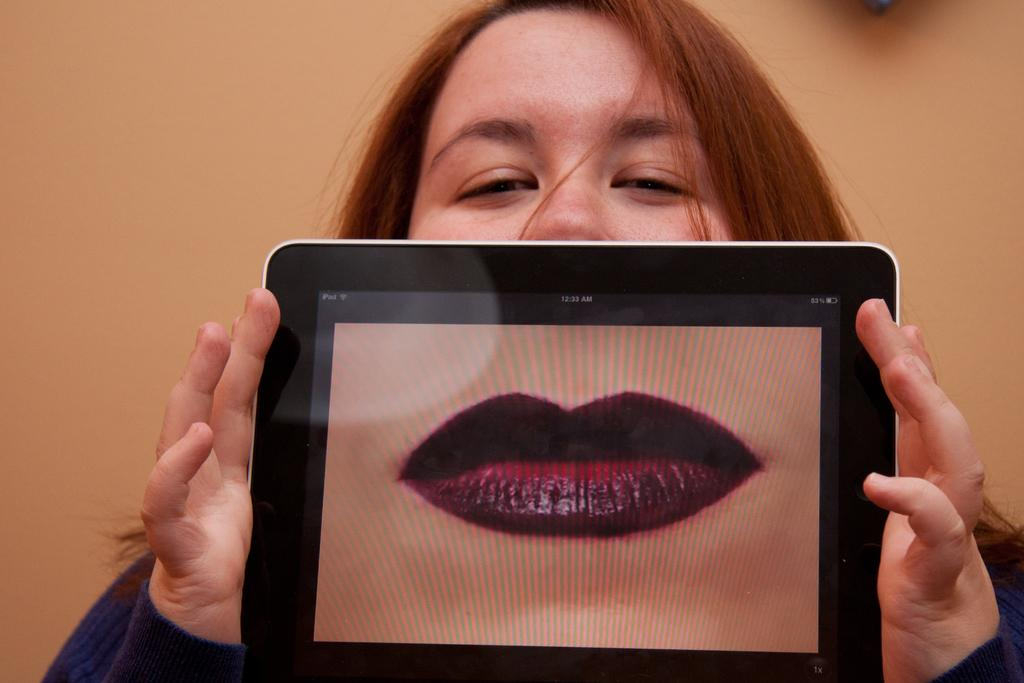Who is the main subject in the image? There is a woman in the image. What is the woman holding in the image? The woman is holding an electronic gadget. Can you describe the electronic gadget? The electronic gadget has visible lips on it. How would you describe the background of the image? The background of the image is blurred. What time of day is it in the image, and how does the woman show fear? The time of day is not mentioned in the image, and there is no indication of fear shown by the woman. 